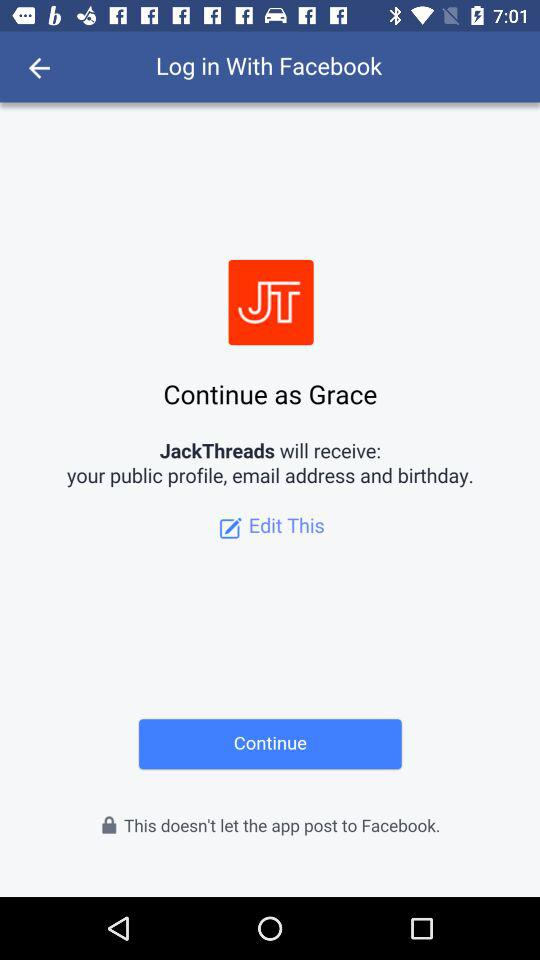What application is asking for permission? The application asking for permission is "JackThreads". 